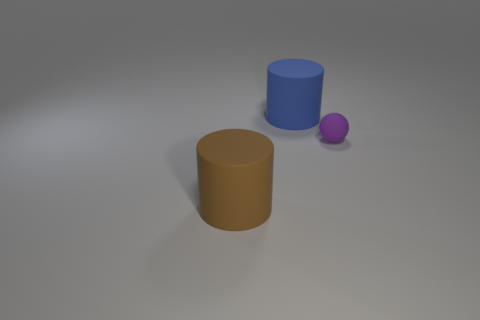There is a big brown object; does it have the same shape as the rubber object right of the large blue rubber cylinder?
Provide a short and direct response. No. Are there an equal number of tiny things to the right of the tiny rubber object and blue things on the left side of the brown thing?
Give a very brief answer. Yes. What number of other things are there of the same material as the purple thing
Your answer should be compact. 2. What number of rubber objects are either big brown cylinders or tiny brown cylinders?
Give a very brief answer. 1. Does the large blue object that is on the left side of the sphere have the same shape as the brown object?
Make the answer very short. Yes. Is the number of brown objects that are to the right of the small purple matte ball greater than the number of cylinders?
Offer a very short reply. No. What number of matte things are both right of the blue thing and left of the tiny matte object?
Your answer should be compact. 0. There is a large thing to the left of the big thing behind the large brown rubber thing; what is its color?
Provide a short and direct response. Brown. How many objects are the same color as the ball?
Your answer should be compact. 0. There is a tiny ball; is its color the same as the big object that is to the left of the blue object?
Offer a terse response. No. 